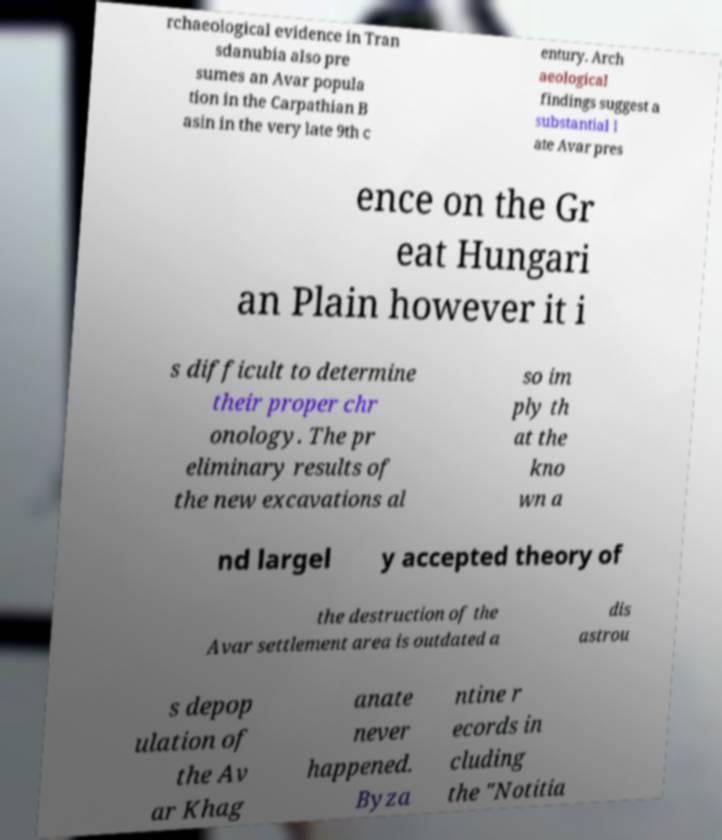Please read and relay the text visible in this image. What does it say? rchaeological evidence in Tran sdanubia also pre sumes an Avar popula tion in the Carpathian B asin in the very late 9th c entury. Arch aeological findings suggest a substantial l ate Avar pres ence on the Gr eat Hungari an Plain however it i s difficult to determine their proper chr onology. The pr eliminary results of the new excavations al so im ply th at the kno wn a nd largel y accepted theory of the destruction of the Avar settlement area is outdated a dis astrou s depop ulation of the Av ar Khag anate never happened. Byza ntine r ecords in cluding the "Notitia 